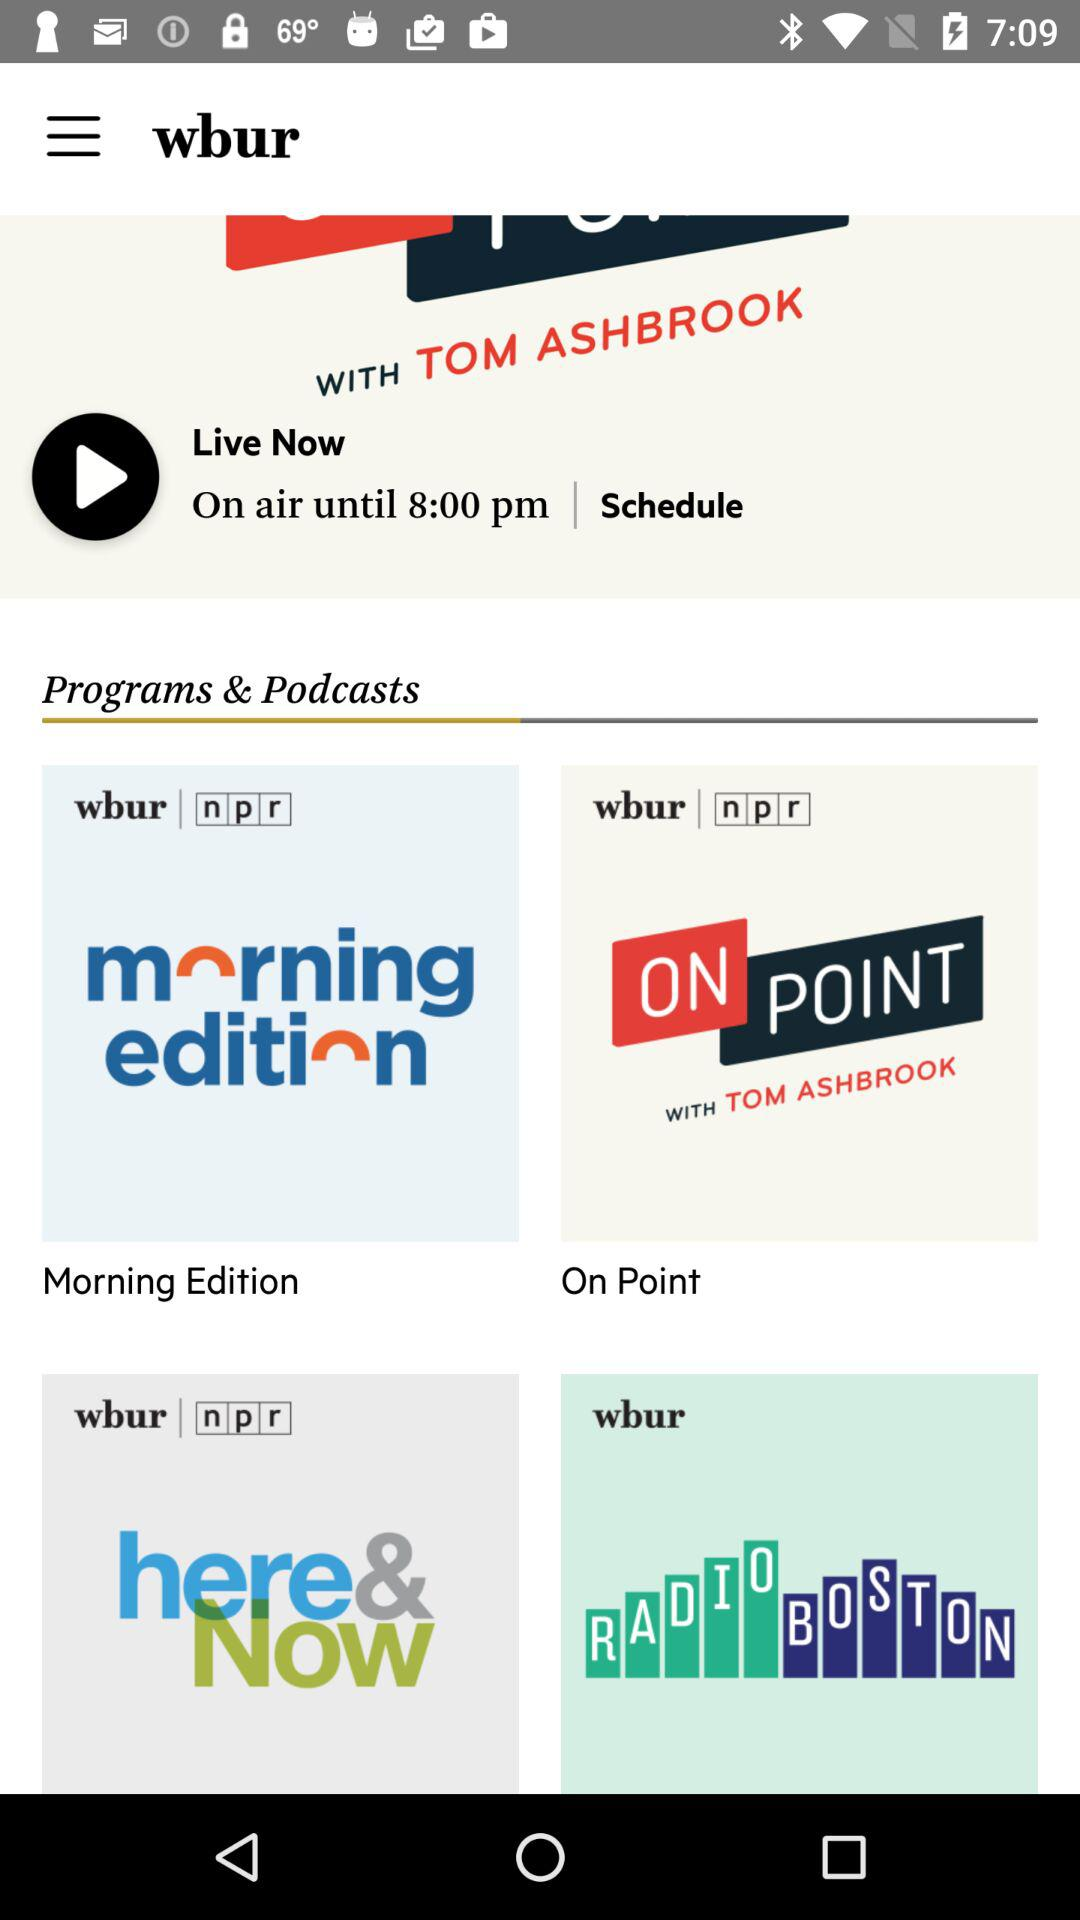How many episodes of "morning edition" are available to stream?
When the provided information is insufficient, respond with <no answer>. <no answer> 